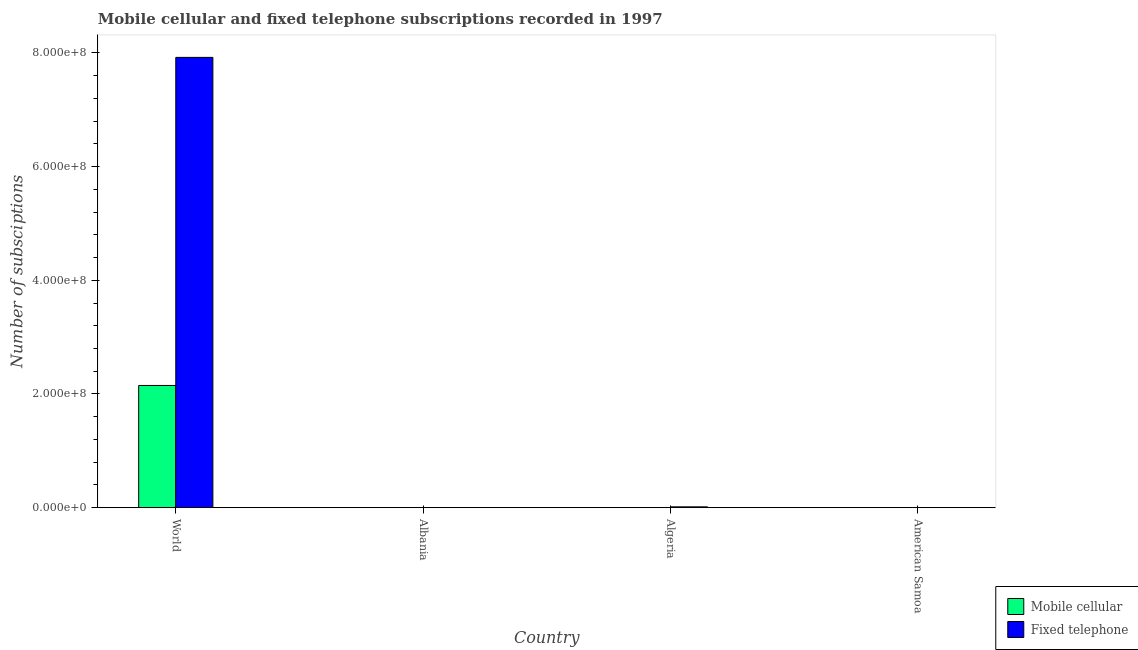How many groups of bars are there?
Provide a succinct answer. 4. Are the number of bars on each tick of the X-axis equal?
Offer a terse response. Yes. How many bars are there on the 3rd tick from the left?
Your answer should be very brief. 2. How many bars are there on the 2nd tick from the right?
Provide a succinct answer. 2. What is the label of the 1st group of bars from the left?
Offer a terse response. World. What is the number of mobile cellular subscriptions in Algeria?
Your response must be concise. 1.74e+04. Across all countries, what is the maximum number of fixed telephone subscriptions?
Keep it short and to the point. 7.92e+08. Across all countries, what is the minimum number of fixed telephone subscriptions?
Your answer should be compact. 1.01e+04. In which country was the number of fixed telephone subscriptions minimum?
Offer a very short reply. American Samoa. What is the total number of mobile cellular subscriptions in the graph?
Offer a very short reply. 2.15e+08. What is the difference between the number of mobile cellular subscriptions in Algeria and that in World?
Give a very brief answer. -2.15e+08. What is the difference between the number of mobile cellular subscriptions in Algeria and the number of fixed telephone subscriptions in American Samoa?
Your response must be concise. 7300. What is the average number of mobile cellular subscriptions per country?
Make the answer very short. 5.37e+07. What is the difference between the number of mobile cellular subscriptions and number of fixed telephone subscriptions in World?
Make the answer very short. -5.77e+08. What is the ratio of the number of mobile cellular subscriptions in Albania to that in American Samoa?
Give a very brief answer. 2.36. Is the number of mobile cellular subscriptions in Albania less than that in Algeria?
Your answer should be compact. Yes. Is the difference between the number of fixed telephone subscriptions in Algeria and American Samoa greater than the difference between the number of mobile cellular subscriptions in Algeria and American Samoa?
Provide a short and direct response. Yes. What is the difference between the highest and the second highest number of fixed telephone subscriptions?
Keep it short and to the point. 7.91e+08. What is the difference between the highest and the lowest number of mobile cellular subscriptions?
Offer a very short reply. 2.15e+08. What does the 2nd bar from the left in Albania represents?
Provide a short and direct response. Fixed telephone. What does the 2nd bar from the right in Algeria represents?
Offer a very short reply. Mobile cellular. How many bars are there?
Provide a short and direct response. 8. Are all the bars in the graph horizontal?
Keep it short and to the point. No. What is the difference between two consecutive major ticks on the Y-axis?
Provide a succinct answer. 2.00e+08. Are the values on the major ticks of Y-axis written in scientific E-notation?
Your answer should be compact. Yes. Does the graph contain any zero values?
Offer a very short reply. No. Where does the legend appear in the graph?
Provide a short and direct response. Bottom right. How many legend labels are there?
Keep it short and to the point. 2. How are the legend labels stacked?
Offer a terse response. Vertical. What is the title of the graph?
Give a very brief answer. Mobile cellular and fixed telephone subscriptions recorded in 1997. What is the label or title of the Y-axis?
Offer a terse response. Number of subsciptions. What is the Number of subsciptions of Mobile cellular in World?
Offer a very short reply. 2.15e+08. What is the Number of subsciptions of Fixed telephone in World?
Keep it short and to the point. 7.92e+08. What is the Number of subsciptions in Mobile cellular in Albania?
Your answer should be very brief. 3300. What is the Number of subsciptions in Fixed telephone in Albania?
Give a very brief answer. 8.68e+04. What is the Number of subsciptions in Mobile cellular in Algeria?
Ensure brevity in your answer.  1.74e+04. What is the Number of subsciptions in Fixed telephone in Algeria?
Make the answer very short. 1.40e+06. What is the Number of subsciptions in Mobile cellular in American Samoa?
Provide a short and direct response. 1400. What is the Number of subsciptions of Fixed telephone in American Samoa?
Provide a short and direct response. 1.01e+04. Across all countries, what is the maximum Number of subsciptions of Mobile cellular?
Provide a short and direct response. 2.15e+08. Across all countries, what is the maximum Number of subsciptions in Fixed telephone?
Offer a very short reply. 7.92e+08. Across all countries, what is the minimum Number of subsciptions in Mobile cellular?
Make the answer very short. 1400. Across all countries, what is the minimum Number of subsciptions of Fixed telephone?
Offer a very short reply. 1.01e+04. What is the total Number of subsciptions in Mobile cellular in the graph?
Offer a very short reply. 2.15e+08. What is the total Number of subsciptions in Fixed telephone in the graph?
Your answer should be very brief. 7.94e+08. What is the difference between the Number of subsciptions of Mobile cellular in World and that in Albania?
Provide a short and direct response. 2.15e+08. What is the difference between the Number of subsciptions of Fixed telephone in World and that in Albania?
Provide a succinct answer. 7.92e+08. What is the difference between the Number of subsciptions of Mobile cellular in World and that in Algeria?
Provide a succinct answer. 2.15e+08. What is the difference between the Number of subsciptions of Fixed telephone in World and that in Algeria?
Your answer should be compact. 7.91e+08. What is the difference between the Number of subsciptions in Mobile cellular in World and that in American Samoa?
Offer a very short reply. 2.15e+08. What is the difference between the Number of subsciptions of Fixed telephone in World and that in American Samoa?
Give a very brief answer. 7.92e+08. What is the difference between the Number of subsciptions of Mobile cellular in Albania and that in Algeria?
Keep it short and to the point. -1.41e+04. What is the difference between the Number of subsciptions of Fixed telephone in Albania and that in Algeria?
Your answer should be compact. -1.31e+06. What is the difference between the Number of subsciptions of Mobile cellular in Albania and that in American Samoa?
Your answer should be compact. 1900. What is the difference between the Number of subsciptions in Fixed telephone in Albania and that in American Samoa?
Your answer should be very brief. 7.67e+04. What is the difference between the Number of subsciptions of Mobile cellular in Algeria and that in American Samoa?
Provide a succinct answer. 1.60e+04. What is the difference between the Number of subsciptions of Fixed telephone in Algeria and that in American Samoa?
Offer a very short reply. 1.39e+06. What is the difference between the Number of subsciptions of Mobile cellular in World and the Number of subsciptions of Fixed telephone in Albania?
Keep it short and to the point. 2.15e+08. What is the difference between the Number of subsciptions in Mobile cellular in World and the Number of subsciptions in Fixed telephone in Algeria?
Keep it short and to the point. 2.14e+08. What is the difference between the Number of subsciptions of Mobile cellular in World and the Number of subsciptions of Fixed telephone in American Samoa?
Your response must be concise. 2.15e+08. What is the difference between the Number of subsciptions of Mobile cellular in Albania and the Number of subsciptions of Fixed telephone in Algeria?
Make the answer very short. -1.40e+06. What is the difference between the Number of subsciptions in Mobile cellular in Albania and the Number of subsciptions in Fixed telephone in American Samoa?
Provide a succinct answer. -6800. What is the difference between the Number of subsciptions of Mobile cellular in Algeria and the Number of subsciptions of Fixed telephone in American Samoa?
Give a very brief answer. 7300. What is the average Number of subsciptions of Mobile cellular per country?
Keep it short and to the point. 5.37e+07. What is the average Number of subsciptions of Fixed telephone per country?
Offer a very short reply. 1.98e+08. What is the difference between the Number of subsciptions in Mobile cellular and Number of subsciptions in Fixed telephone in World?
Make the answer very short. -5.77e+08. What is the difference between the Number of subsciptions of Mobile cellular and Number of subsciptions of Fixed telephone in Albania?
Offer a very short reply. -8.35e+04. What is the difference between the Number of subsciptions in Mobile cellular and Number of subsciptions in Fixed telephone in Algeria?
Keep it short and to the point. -1.38e+06. What is the difference between the Number of subsciptions of Mobile cellular and Number of subsciptions of Fixed telephone in American Samoa?
Ensure brevity in your answer.  -8700. What is the ratio of the Number of subsciptions in Mobile cellular in World to that in Albania?
Provide a succinct answer. 6.51e+04. What is the ratio of the Number of subsciptions in Fixed telephone in World to that in Albania?
Provide a short and direct response. 9125.27. What is the ratio of the Number of subsciptions in Mobile cellular in World to that in Algeria?
Keep it short and to the point. 1.24e+04. What is the ratio of the Number of subsciptions in Fixed telephone in World to that in Algeria?
Offer a terse response. 565.63. What is the ratio of the Number of subsciptions in Mobile cellular in World to that in American Samoa?
Offer a very short reply. 1.54e+05. What is the ratio of the Number of subsciptions of Fixed telephone in World to that in American Samoa?
Your response must be concise. 7.84e+04. What is the ratio of the Number of subsciptions of Mobile cellular in Albania to that in Algeria?
Offer a very short reply. 0.19. What is the ratio of the Number of subsciptions of Fixed telephone in Albania to that in Algeria?
Offer a terse response. 0.06. What is the ratio of the Number of subsciptions in Mobile cellular in Albania to that in American Samoa?
Ensure brevity in your answer.  2.36. What is the ratio of the Number of subsciptions of Fixed telephone in Albania to that in American Samoa?
Your response must be concise. 8.59. What is the ratio of the Number of subsciptions in Mobile cellular in Algeria to that in American Samoa?
Provide a succinct answer. 12.43. What is the ratio of the Number of subsciptions in Fixed telephone in Algeria to that in American Samoa?
Your answer should be compact. 138.65. What is the difference between the highest and the second highest Number of subsciptions in Mobile cellular?
Your response must be concise. 2.15e+08. What is the difference between the highest and the second highest Number of subsciptions of Fixed telephone?
Provide a short and direct response. 7.91e+08. What is the difference between the highest and the lowest Number of subsciptions of Mobile cellular?
Ensure brevity in your answer.  2.15e+08. What is the difference between the highest and the lowest Number of subsciptions in Fixed telephone?
Give a very brief answer. 7.92e+08. 